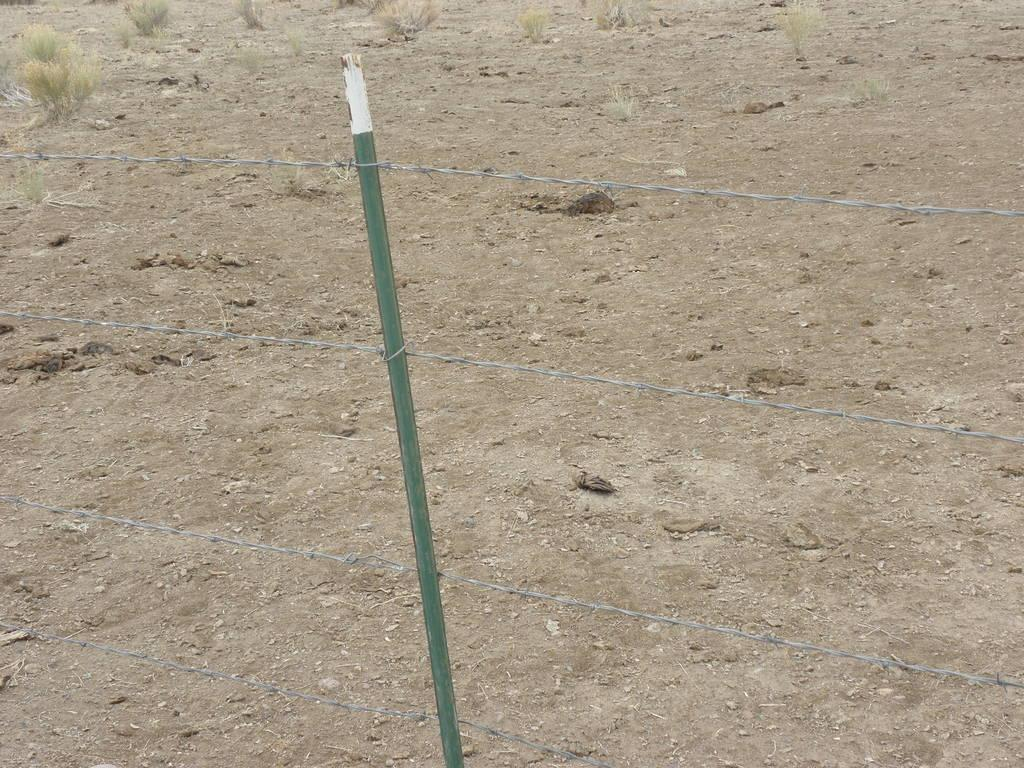What is present in the image that serves as a barrier or divider? There is a fence in the image. What type of natural environment can be seen in the background of the image? There is grass visible in the background of the image. What type of ticket can be seen being used to repair the fence in the image? There is no ticket present in the image, and the fence does not appear to be in need of repair. 